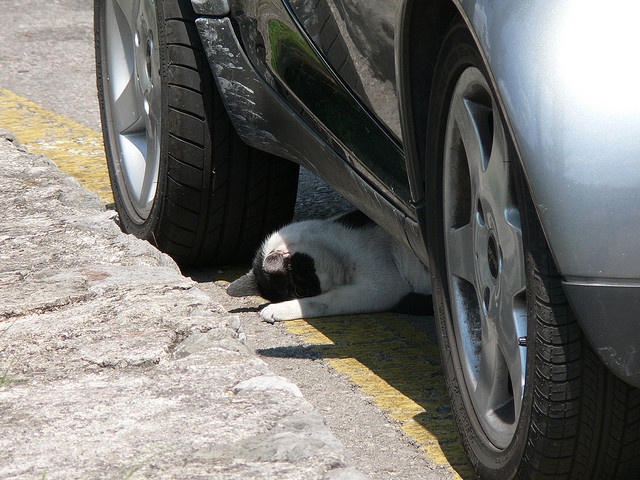Describe the objects in this image and their specific colors. I can see car in darkgray, black, gray, and white tones and cat in darkgray, black, purple, and lightgray tones in this image. 